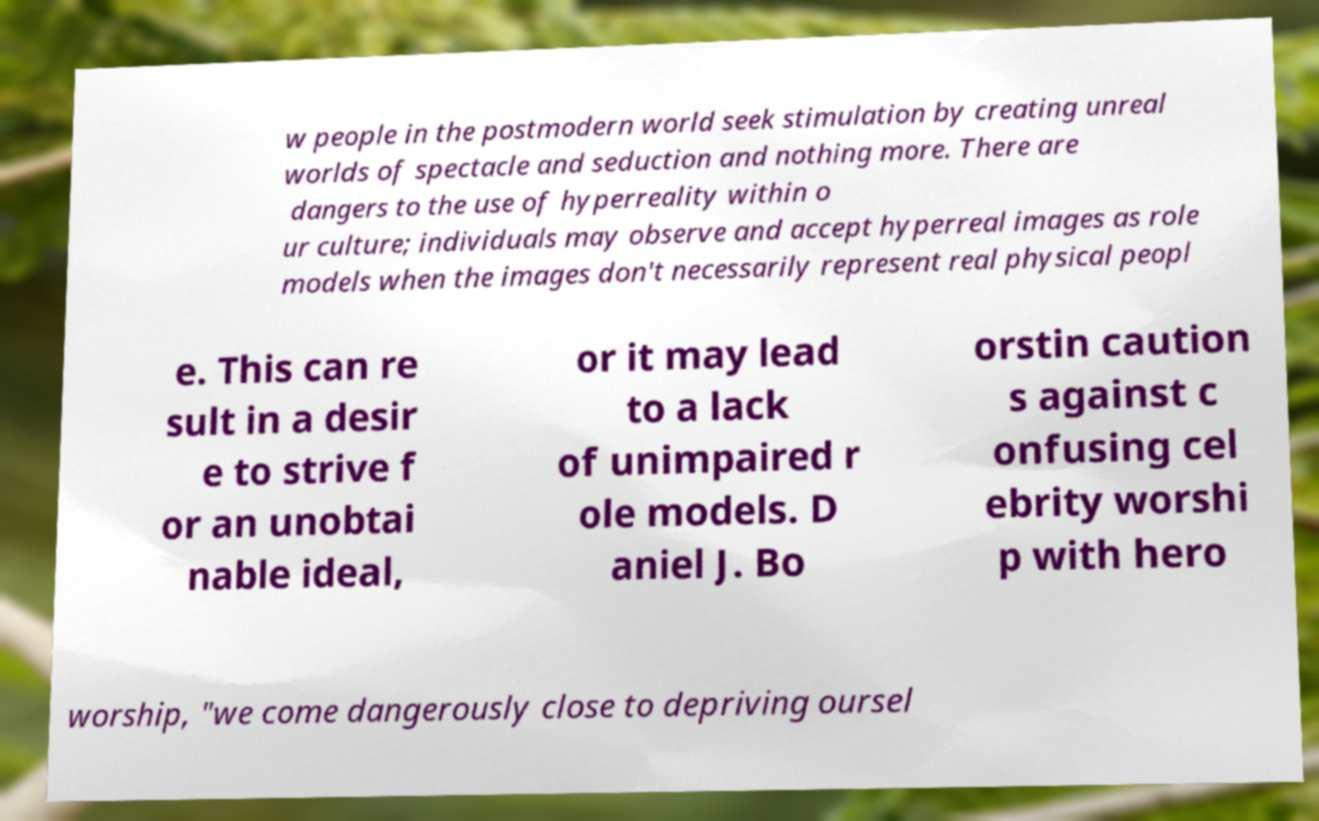Please read and relay the text visible in this image. What does it say? w people in the postmodern world seek stimulation by creating unreal worlds of spectacle and seduction and nothing more. There are dangers to the use of hyperreality within o ur culture; individuals may observe and accept hyperreal images as role models when the images don't necessarily represent real physical peopl e. This can re sult in a desir e to strive f or an unobtai nable ideal, or it may lead to a lack of unimpaired r ole models. D aniel J. Bo orstin caution s against c onfusing cel ebrity worshi p with hero worship, "we come dangerously close to depriving oursel 